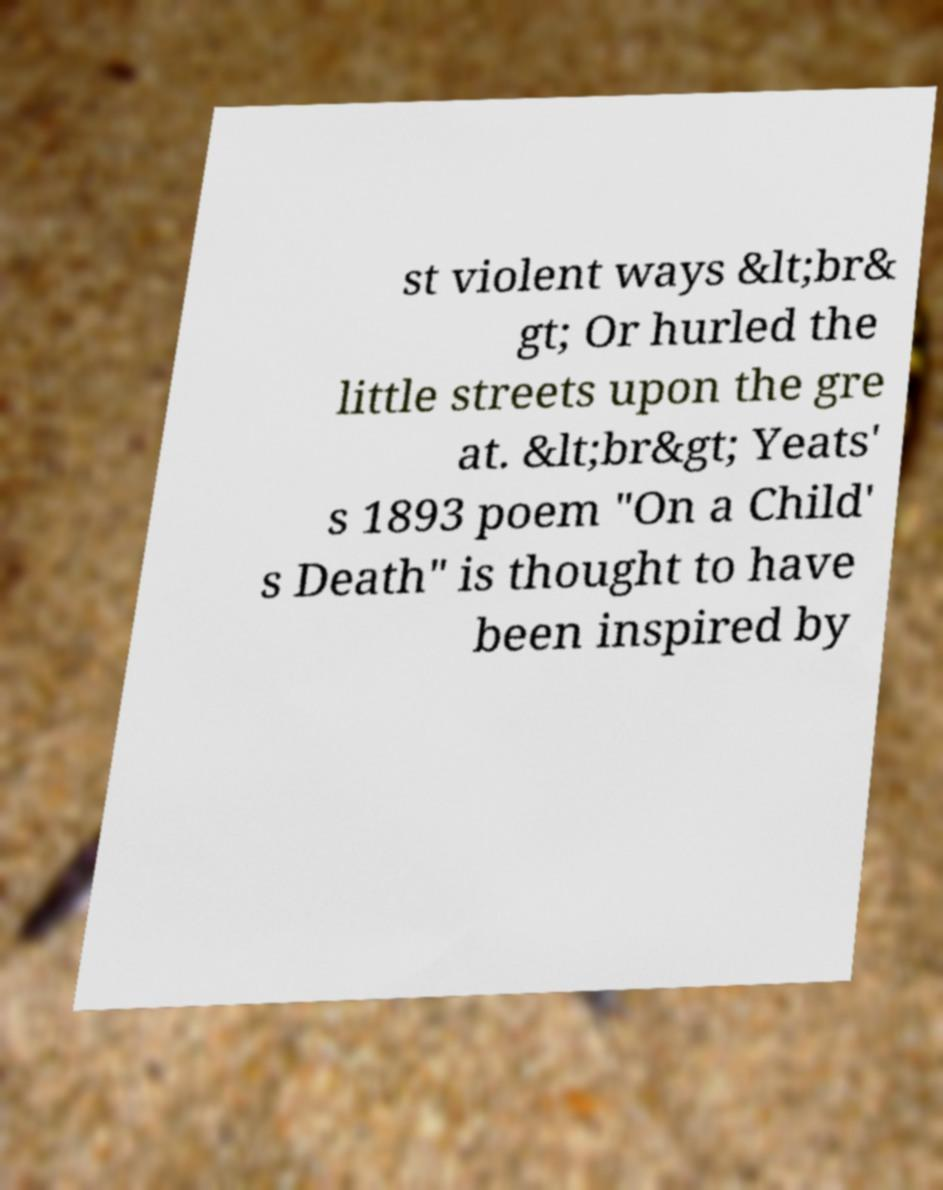There's text embedded in this image that I need extracted. Can you transcribe it verbatim? st violent ways &lt;br& gt; Or hurled the little streets upon the gre at. &lt;br&gt; Yeats' s 1893 poem "On a Child' s Death" is thought to have been inspired by 